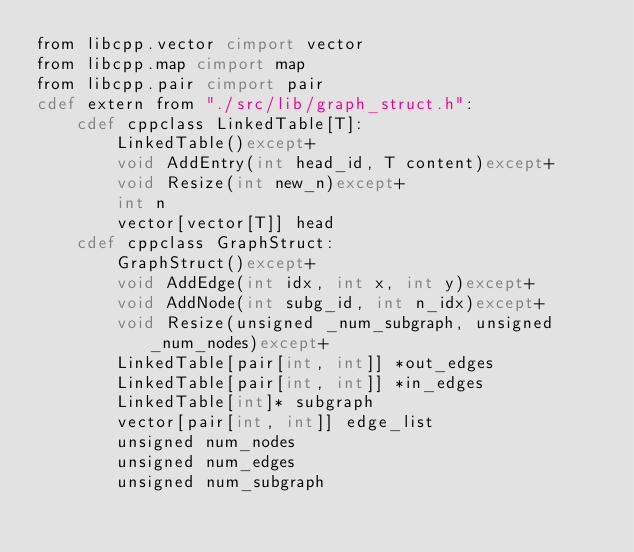Convert code to text. <code><loc_0><loc_0><loc_500><loc_500><_Cython_>from libcpp.vector cimport vector
from libcpp.map cimport map
from libcpp.pair cimport pair
cdef extern from "./src/lib/graph_struct.h":
    cdef cppclass LinkedTable[T]:
        LinkedTable()except+
        void AddEntry(int head_id, T content)except+
        void Resize(int new_n)except+
        int n
        vector[vector[T]] head
    cdef cppclass GraphStruct:
        GraphStruct()except+
        void AddEdge(int idx, int x, int y)except+
        void AddNode(int subg_id, int n_idx)except+
        void Resize(unsigned _num_subgraph, unsigned _num_nodes)except+
        LinkedTable[pair[int, int]] *out_edges
        LinkedTable[pair[int, int]] *in_edges
        LinkedTable[int]* subgraph
        vector[pair[int, int]] edge_list
        unsigned num_nodes
        unsigned num_edges
        unsigned num_subgraph
</code> 